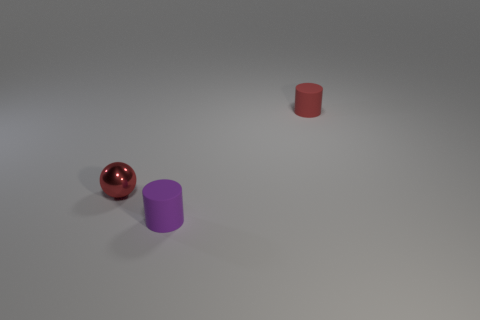How many cubes are big cyan metallic things or purple objects?
Keep it short and to the point. 0. The other thing that is made of the same material as the purple thing is what color?
Offer a very short reply. Red. Is the number of red shiny balls less than the number of small objects?
Your answer should be compact. Yes. There is a tiny red object on the left side of the red rubber object; is it the same shape as the matte object behind the metal ball?
Your answer should be very brief. No. What number of objects are either tiny purple rubber things or matte things?
Your answer should be very brief. 2. The metallic object that is the same size as the purple cylinder is what color?
Your answer should be very brief. Red. What number of purple matte things are behind the small thing in front of the red metallic ball?
Provide a succinct answer. 0. What number of things are both behind the small purple object and on the right side of the small metal thing?
Provide a short and direct response. 1. What number of things are either tiny things left of the purple matte cylinder or small cylinders in front of the tiny red cylinder?
Your response must be concise. 2. What number of other things are there of the same size as the red metallic ball?
Offer a terse response. 2. 